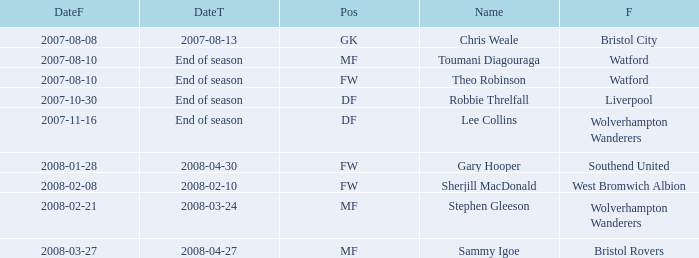Could you parse the entire table as a dict? {'header': ['DateF', 'DateT', 'Pos', 'Name', 'F'], 'rows': [['2007-08-08', '2007-08-13', 'GK', 'Chris Weale', 'Bristol City'], ['2007-08-10', 'End of season', 'MF', 'Toumani Diagouraga', 'Watford'], ['2007-08-10', 'End of season', 'FW', 'Theo Robinson', 'Watford'], ['2007-10-30', 'End of season', 'DF', 'Robbie Threlfall', 'Liverpool'], ['2007-11-16', 'End of season', 'DF', 'Lee Collins', 'Wolverhampton Wanderers'], ['2008-01-28', '2008-04-30', 'FW', 'Gary Hooper', 'Southend United'], ['2008-02-08', '2008-02-10', 'FW', 'Sherjill MacDonald', 'West Bromwich Albion'], ['2008-02-21', '2008-03-24', 'MF', 'Stephen Gleeson', 'Wolverhampton Wanderers'], ['2008-03-27', '2008-04-27', 'MF', 'Sammy Igoe', 'Bristol Rovers']]} What was the from for the Date From of 2007-08-08? Bristol City. 